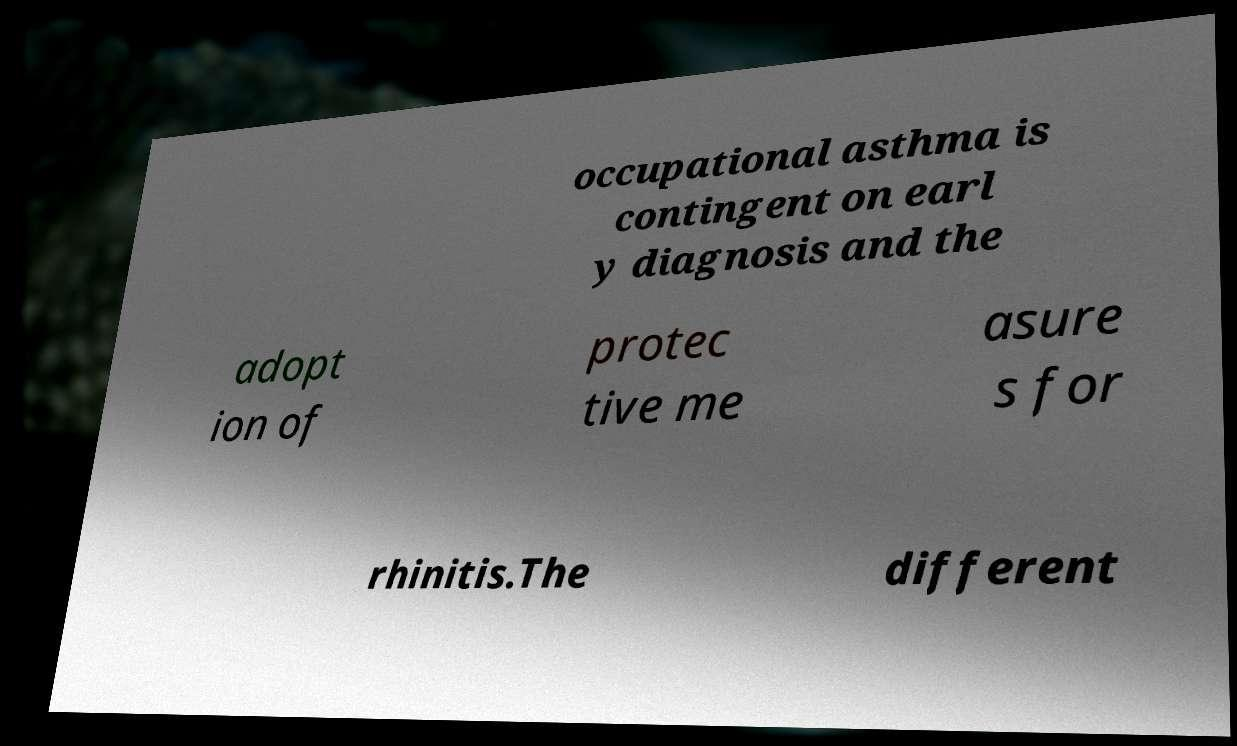I need the written content from this picture converted into text. Can you do that? occupational asthma is contingent on earl y diagnosis and the adopt ion of protec tive me asure s for rhinitis.The different 